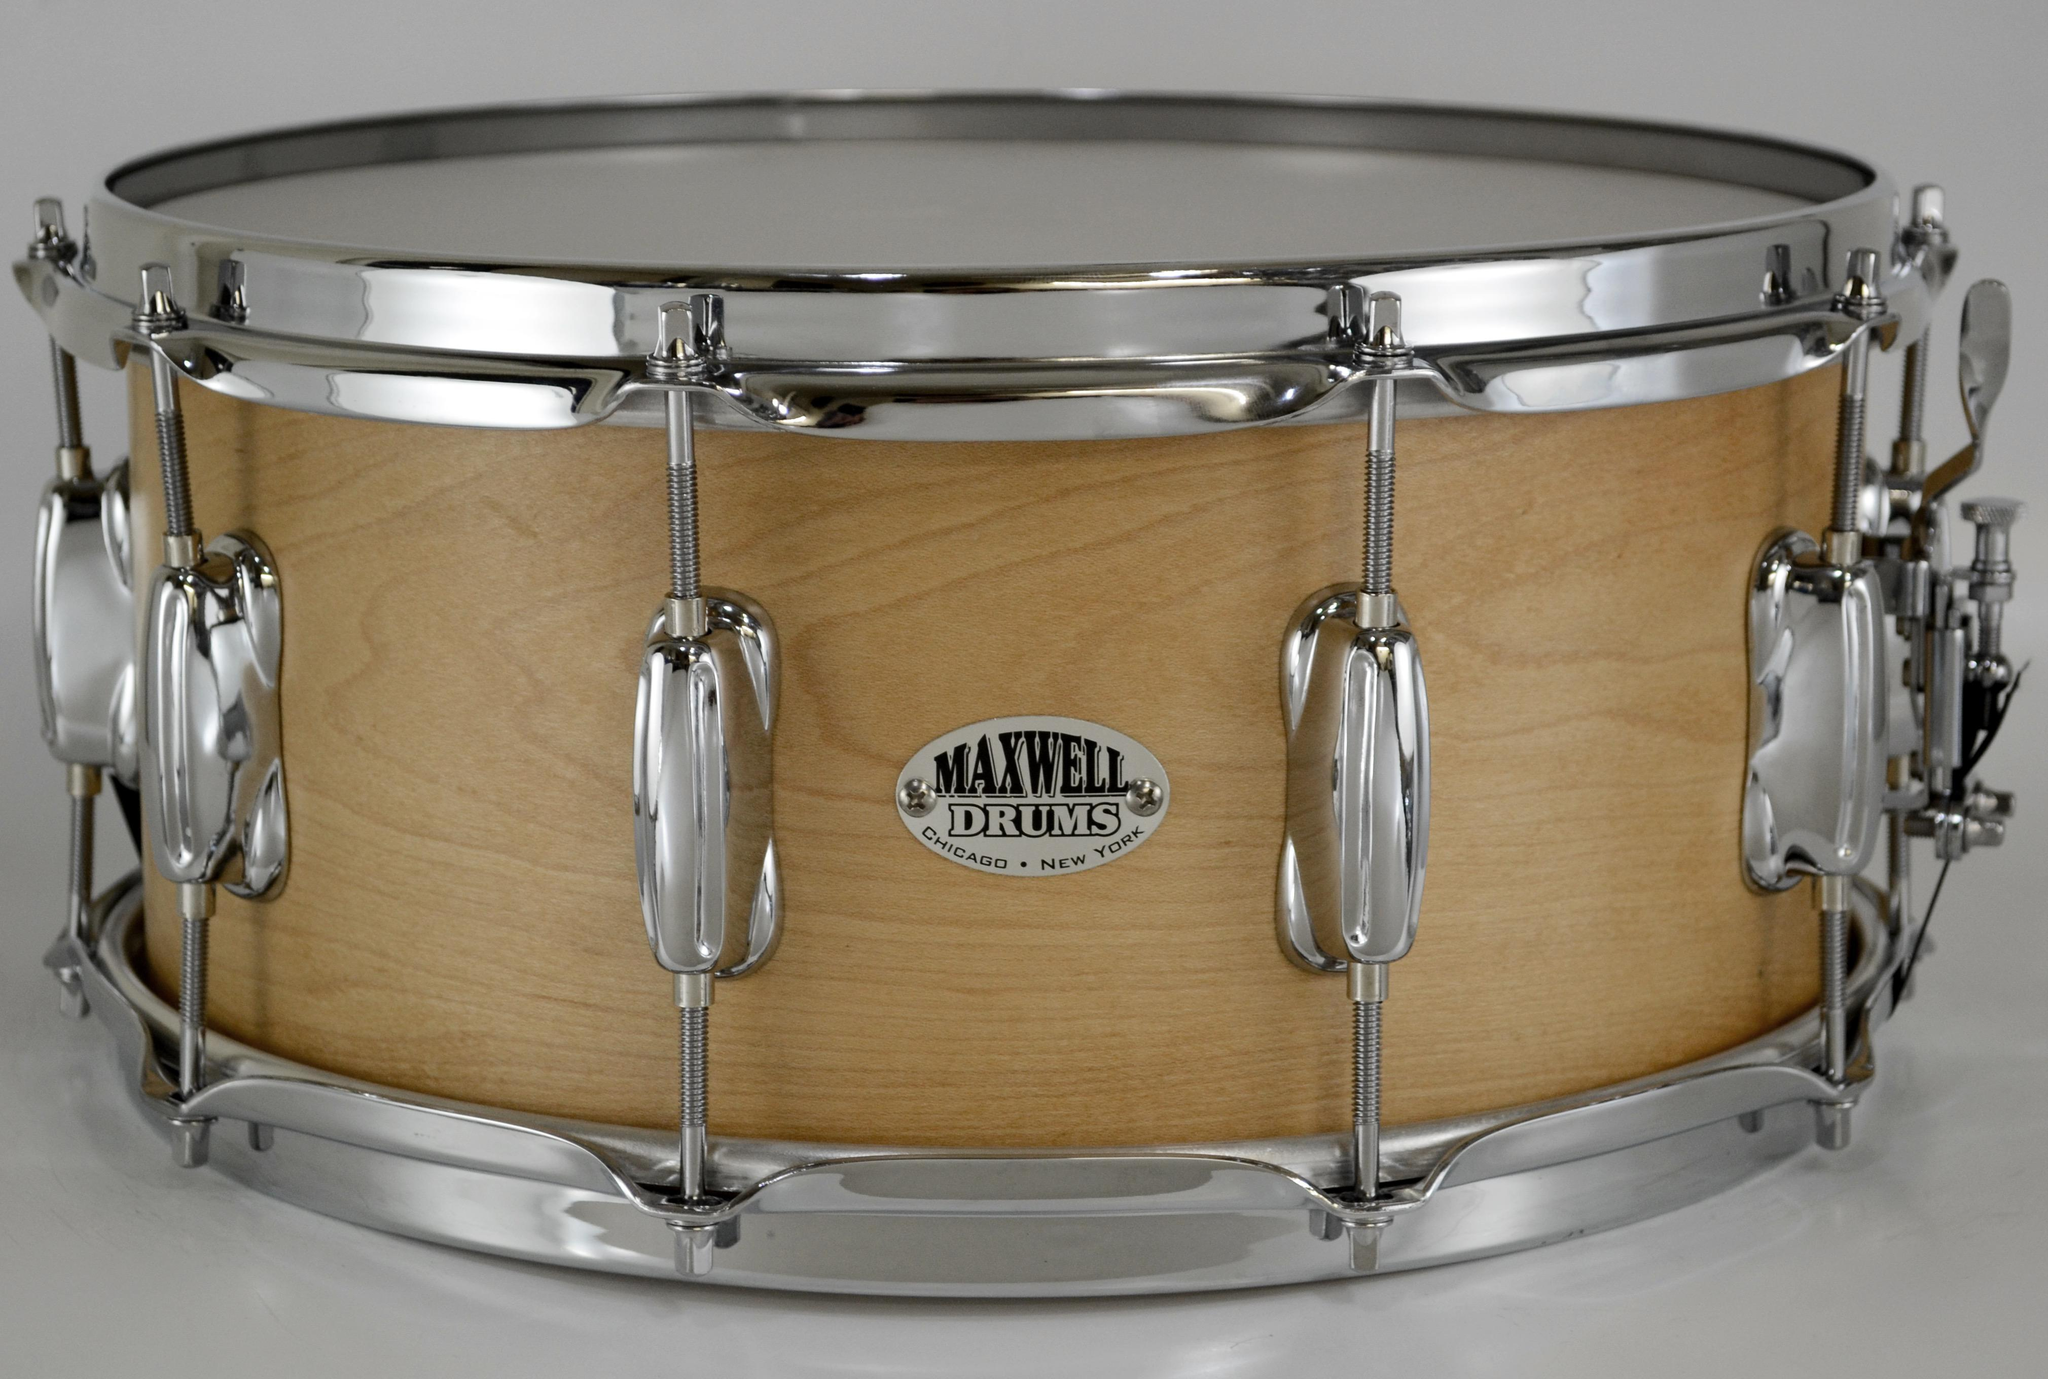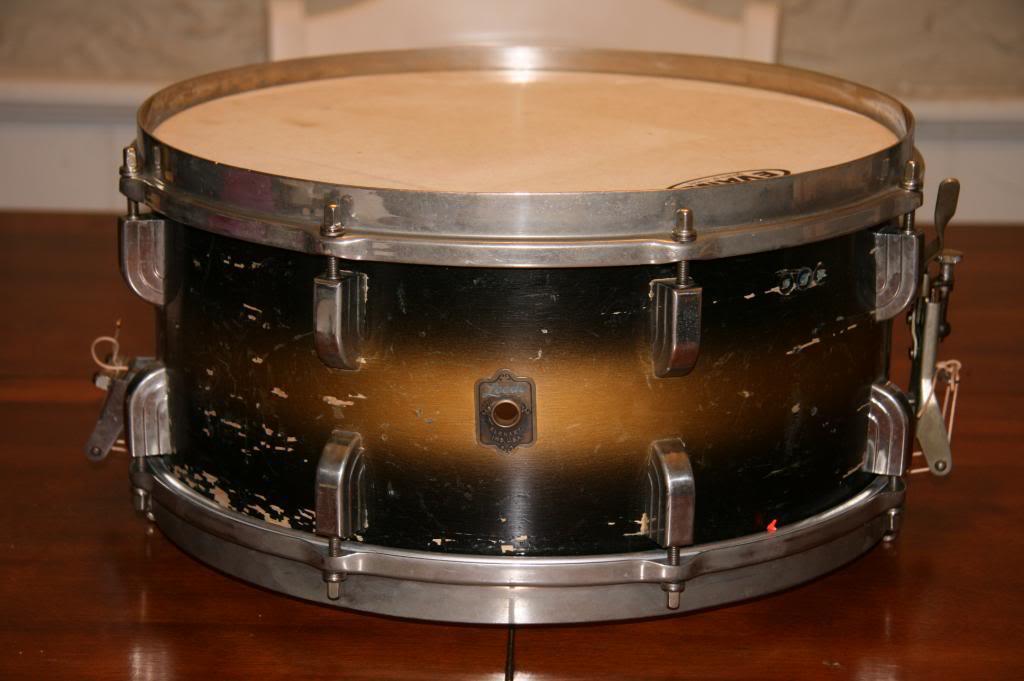The first image is the image on the left, the second image is the image on the right. For the images displayed, is the sentence "One drum contains a silver, oval shaped brand label on the side." factually correct? Answer yes or no. Yes. The first image is the image on the left, the second image is the image on the right. Given the left and right images, does the statement "All drums are lying flat and one drum has an oval label that is facing directly forward." hold true? Answer yes or no. Yes. 